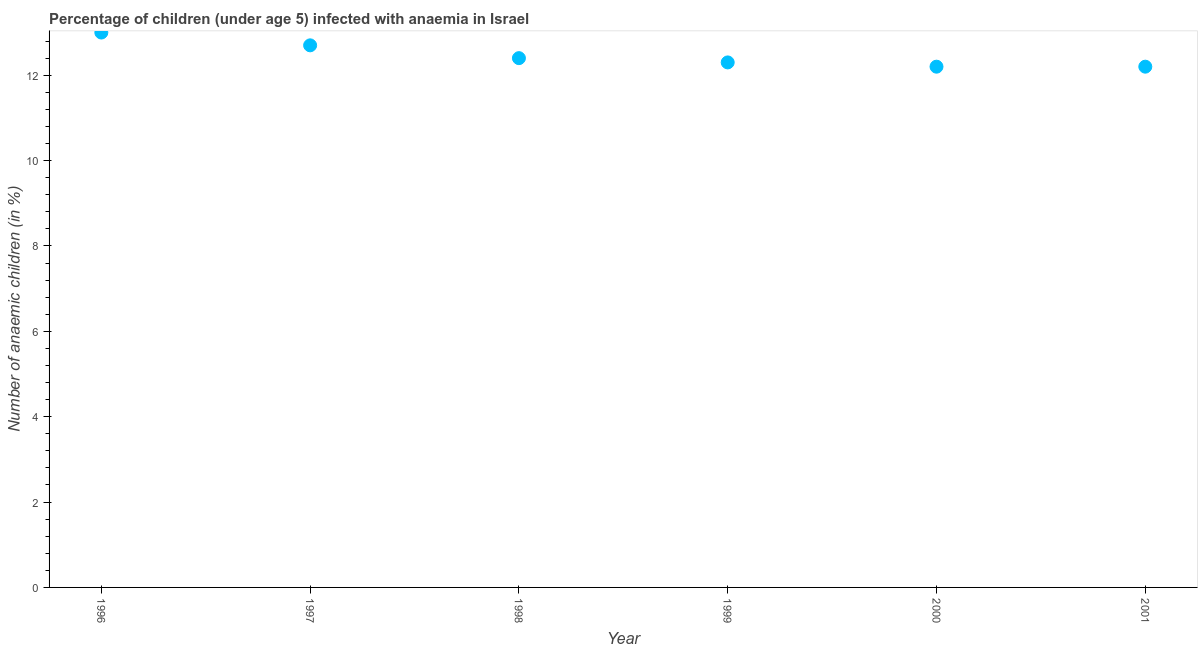What is the number of anaemic children in 1997?
Offer a terse response. 12.7. Across all years, what is the maximum number of anaemic children?
Offer a very short reply. 13. Across all years, what is the minimum number of anaemic children?
Give a very brief answer. 12.2. In which year was the number of anaemic children maximum?
Make the answer very short. 1996. In which year was the number of anaemic children minimum?
Make the answer very short. 2000. What is the sum of the number of anaemic children?
Make the answer very short. 74.8. What is the difference between the number of anaemic children in 1998 and 1999?
Your response must be concise. 0.1. What is the average number of anaemic children per year?
Keep it short and to the point. 12.47. What is the median number of anaemic children?
Provide a succinct answer. 12.35. What is the ratio of the number of anaemic children in 1998 to that in 2000?
Make the answer very short. 1.02. Is the number of anaemic children in 1996 less than that in 1999?
Keep it short and to the point. No. What is the difference between the highest and the second highest number of anaemic children?
Provide a succinct answer. 0.3. What is the difference between the highest and the lowest number of anaemic children?
Your response must be concise. 0.8. How many dotlines are there?
Ensure brevity in your answer.  1. What is the difference between two consecutive major ticks on the Y-axis?
Provide a short and direct response. 2. Does the graph contain grids?
Keep it short and to the point. No. What is the title of the graph?
Give a very brief answer. Percentage of children (under age 5) infected with anaemia in Israel. What is the label or title of the X-axis?
Your answer should be very brief. Year. What is the label or title of the Y-axis?
Give a very brief answer. Number of anaemic children (in %). What is the Number of anaemic children (in %) in 1996?
Make the answer very short. 13. What is the Number of anaemic children (in %) in 1997?
Make the answer very short. 12.7. What is the Number of anaemic children (in %) in 1998?
Make the answer very short. 12.4. What is the Number of anaemic children (in %) in 1999?
Keep it short and to the point. 12.3. What is the difference between the Number of anaemic children (in %) in 1996 and 1997?
Make the answer very short. 0.3. What is the difference between the Number of anaemic children (in %) in 1996 and 1998?
Make the answer very short. 0.6. What is the difference between the Number of anaemic children (in %) in 1996 and 1999?
Offer a terse response. 0.7. What is the difference between the Number of anaemic children (in %) in 1996 and 2001?
Your answer should be compact. 0.8. What is the difference between the Number of anaemic children (in %) in 1997 and 2000?
Your answer should be compact. 0.5. What is the difference between the Number of anaemic children (in %) in 1997 and 2001?
Make the answer very short. 0.5. What is the difference between the Number of anaemic children (in %) in 1998 and 1999?
Your response must be concise. 0.1. What is the ratio of the Number of anaemic children (in %) in 1996 to that in 1998?
Offer a very short reply. 1.05. What is the ratio of the Number of anaemic children (in %) in 1996 to that in 1999?
Your answer should be very brief. 1.06. What is the ratio of the Number of anaemic children (in %) in 1996 to that in 2000?
Give a very brief answer. 1.07. What is the ratio of the Number of anaemic children (in %) in 1996 to that in 2001?
Keep it short and to the point. 1.07. What is the ratio of the Number of anaemic children (in %) in 1997 to that in 1999?
Your answer should be compact. 1.03. What is the ratio of the Number of anaemic children (in %) in 1997 to that in 2000?
Provide a short and direct response. 1.04. What is the ratio of the Number of anaemic children (in %) in 1997 to that in 2001?
Keep it short and to the point. 1.04. What is the ratio of the Number of anaemic children (in %) in 1998 to that in 1999?
Your response must be concise. 1.01. What is the ratio of the Number of anaemic children (in %) in 1999 to that in 2001?
Ensure brevity in your answer.  1.01. 